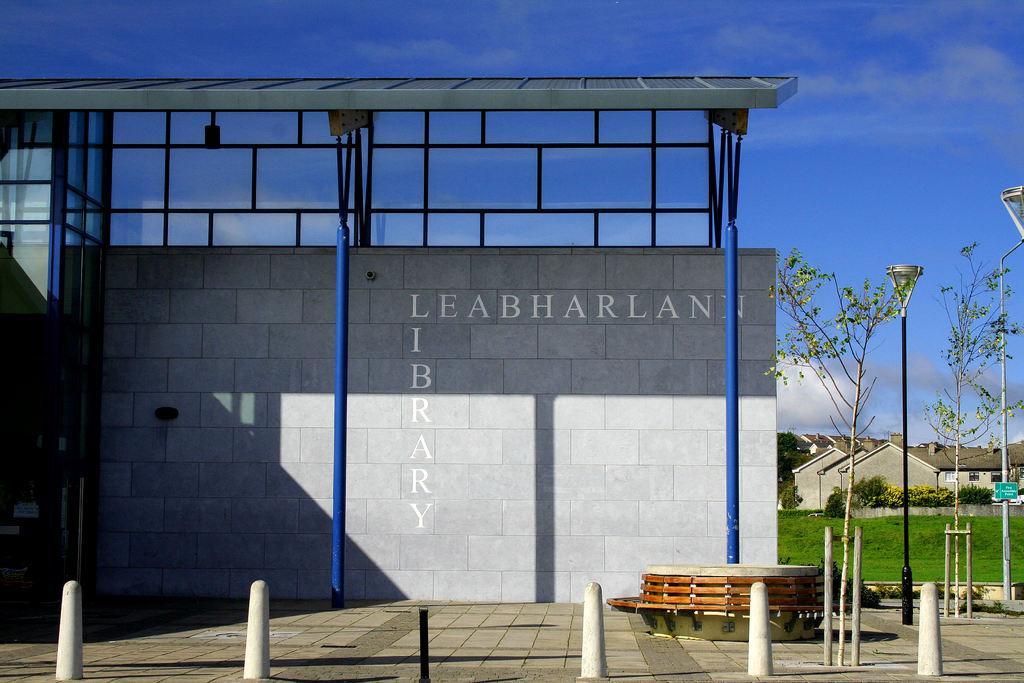In one or two sentences, can you explain what this image depicts? In this image I can see a wall with some text written on it. In the background, I can see the grass, the houses and clouds in the sky. 